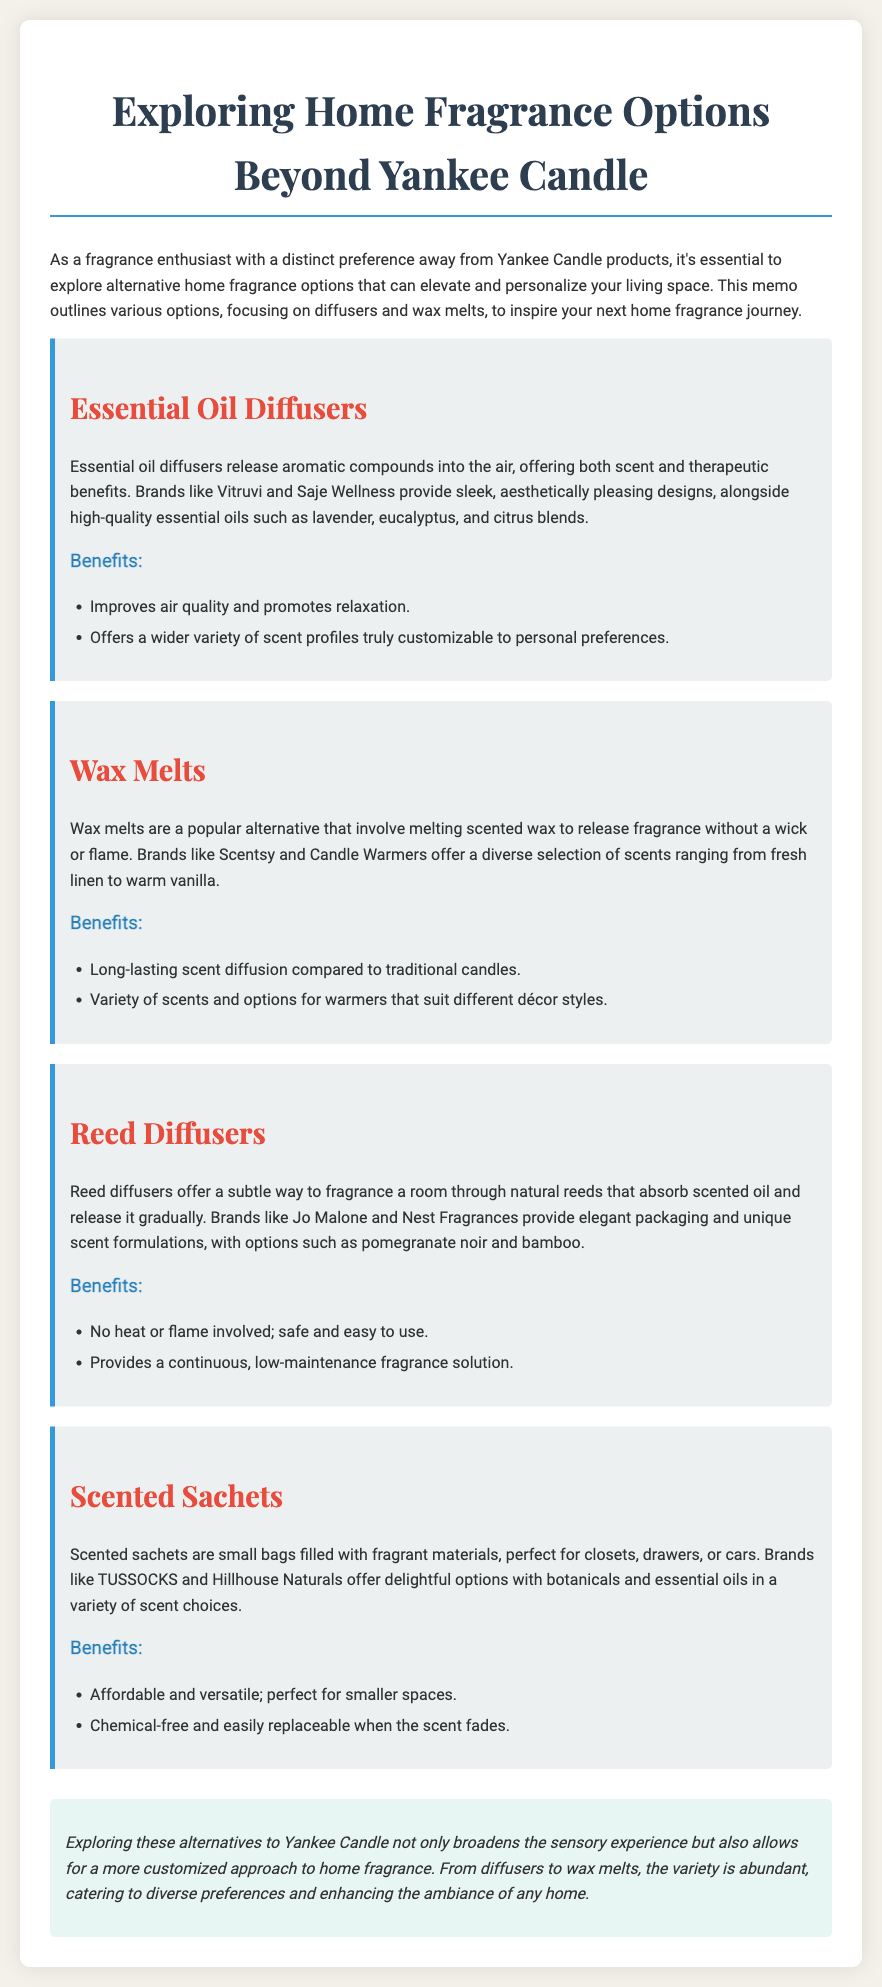What are essential oil diffusers used for? Essential oil diffusers release aromatic compounds into the air, offering both scent and therapeutic benefits.
Answer: Scent and therapeutic benefits Which brands are mentioned for essential oil diffusers? The document lists Vitruvi and Saje Wellness as brands for essential oil diffusers.
Answer: Vitruvi and Saje Wellness What type of wax melts do Scentsy and Candle Warmers offer? They provide a diverse selection of scents ranging from fresh linen to warm vanilla.
Answer: Diverse selection of scents What is one benefit of reed diffusers? Reed diffusers provide a continuous, low-maintenance fragrance solution.
Answer: Low-maintenance fragrance solution What can scented sachets be used for? Scented sachets are perfect for closets, drawers, or cars.
Answer: Closets, drawers, or cars How are wax melts different from traditional candles? Wax melts involve melting scented wax to release fragrance without a wick or flame.
Answer: No wick or flame What is a unique scent formulation mentioned for reed diffusers? The document mentions pomegranate noir as a unique scent formulation for reed diffusers.
Answer: Pomegranate noir What is a characteristic benefit of scented sachets? Scented sachets are chemical-free and easily replaceable when the scent fades.
Answer: Chemical-free and easily replaceable 